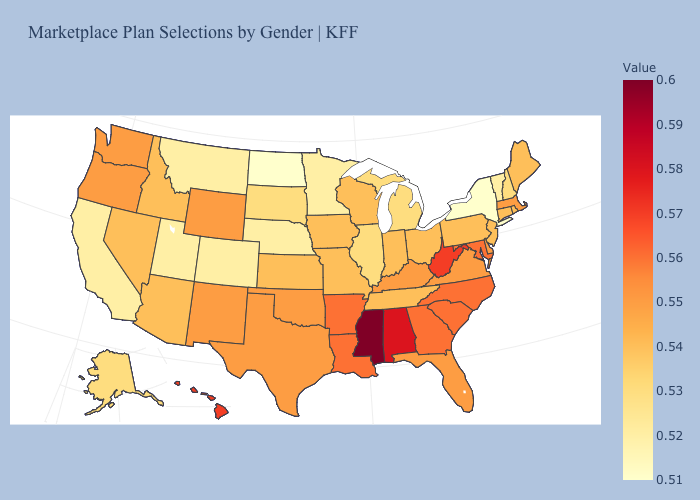Does the map have missing data?
Keep it brief. No. Among the states that border Vermont , does New York have the lowest value?
Quick response, please. Yes. Which states hav the highest value in the West?
Give a very brief answer. Hawaii. Which states have the lowest value in the West?
Give a very brief answer. California, Colorado, Montana, Utah. Which states have the highest value in the USA?
Be succinct. Mississippi. Does the map have missing data?
Answer briefly. No. Does Mississippi have the highest value in the South?
Answer briefly. Yes. Which states have the lowest value in the USA?
Write a very short answer. New York, North Dakota. 